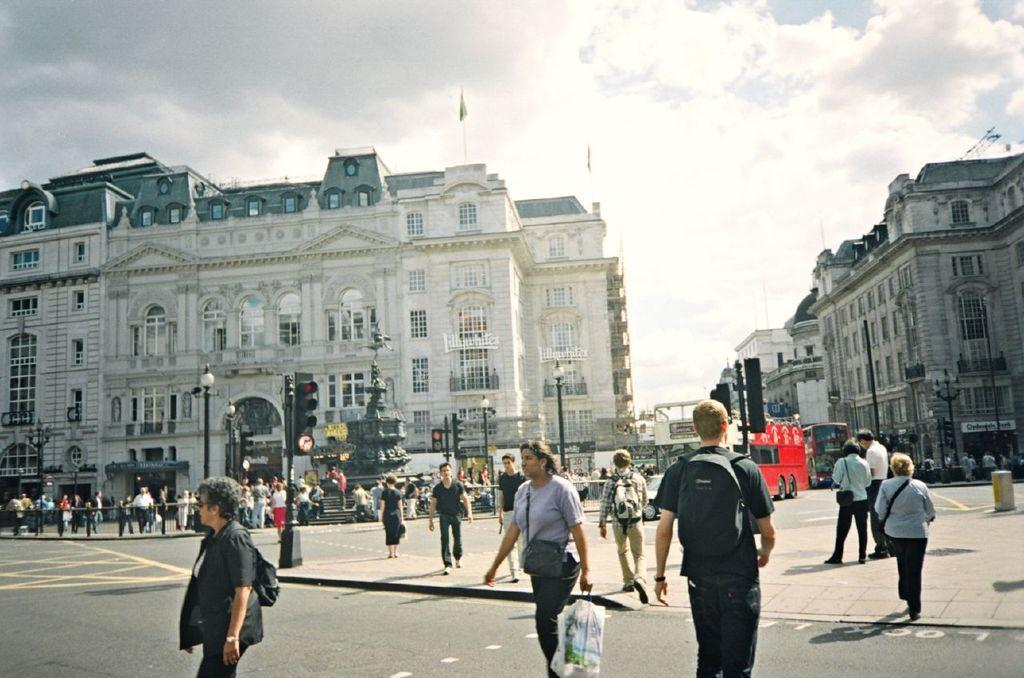What are the people in the image doing? There is a group of people walking on the road in the image. What type of vehicles can be seen in the image? There are buses in the image. What controls the traffic flow in the image? A traffic signal light is present in the image. What structures are present along the road? There are poles in the image. What can be seen in the background of the image? The sky with clouds is visible in the background. What type of doll is sitting on top of the bus in the image? There is no doll present on top of the bus in the image. What company owns the buses in the image? The image does not provide information about the ownership of the buses. 